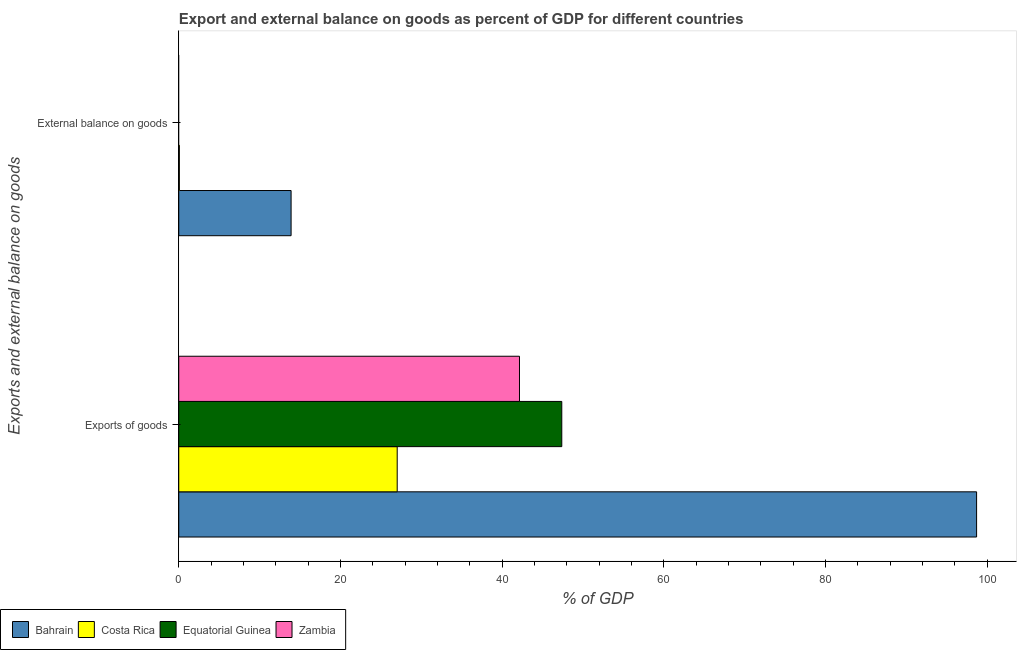How many groups of bars are there?
Your answer should be very brief. 2. Are the number of bars on each tick of the Y-axis equal?
Provide a succinct answer. No. How many bars are there on the 2nd tick from the top?
Your response must be concise. 4. What is the label of the 2nd group of bars from the top?
Your answer should be compact. Exports of goods. What is the external balance on goods as percentage of gdp in Costa Rica?
Your answer should be very brief. 0.07. Across all countries, what is the maximum export of goods as percentage of gdp?
Offer a terse response. 98.71. Across all countries, what is the minimum export of goods as percentage of gdp?
Make the answer very short. 27.03. In which country was the export of goods as percentage of gdp maximum?
Provide a short and direct response. Bahrain. What is the total external balance on goods as percentage of gdp in the graph?
Provide a short and direct response. 13.97. What is the difference between the external balance on goods as percentage of gdp in Bahrain and that in Costa Rica?
Offer a very short reply. 13.83. What is the difference between the external balance on goods as percentage of gdp in Zambia and the export of goods as percentage of gdp in Bahrain?
Keep it short and to the point. -98.71. What is the average export of goods as percentage of gdp per country?
Offer a terse response. 53.82. What is the difference between the export of goods as percentage of gdp and external balance on goods as percentage of gdp in Costa Rica?
Your answer should be very brief. 26.95. What is the ratio of the export of goods as percentage of gdp in Costa Rica to that in Equatorial Guinea?
Give a very brief answer. 0.57. Is the export of goods as percentage of gdp in Zambia less than that in Equatorial Guinea?
Provide a short and direct response. Yes. In how many countries, is the export of goods as percentage of gdp greater than the average export of goods as percentage of gdp taken over all countries?
Provide a succinct answer. 1. How many bars are there?
Your answer should be compact. 6. How many countries are there in the graph?
Make the answer very short. 4. Are the values on the major ticks of X-axis written in scientific E-notation?
Ensure brevity in your answer.  No. Where does the legend appear in the graph?
Your response must be concise. Bottom left. How many legend labels are there?
Keep it short and to the point. 4. What is the title of the graph?
Your answer should be compact. Export and external balance on goods as percent of GDP for different countries. What is the label or title of the X-axis?
Provide a short and direct response. % of GDP. What is the label or title of the Y-axis?
Offer a very short reply. Exports and external balance on goods. What is the % of GDP in Bahrain in Exports of goods?
Ensure brevity in your answer.  98.71. What is the % of GDP in Costa Rica in Exports of goods?
Your response must be concise. 27.03. What is the % of GDP in Equatorial Guinea in Exports of goods?
Your response must be concise. 47.39. What is the % of GDP in Zambia in Exports of goods?
Provide a succinct answer. 42.15. What is the % of GDP in Bahrain in External balance on goods?
Ensure brevity in your answer.  13.9. What is the % of GDP in Costa Rica in External balance on goods?
Make the answer very short. 0.07. What is the % of GDP of Equatorial Guinea in External balance on goods?
Offer a terse response. 0. Across all Exports and external balance on goods, what is the maximum % of GDP of Bahrain?
Keep it short and to the point. 98.71. Across all Exports and external balance on goods, what is the maximum % of GDP of Costa Rica?
Make the answer very short. 27.03. Across all Exports and external balance on goods, what is the maximum % of GDP in Equatorial Guinea?
Your answer should be very brief. 47.39. Across all Exports and external balance on goods, what is the maximum % of GDP of Zambia?
Give a very brief answer. 42.15. Across all Exports and external balance on goods, what is the minimum % of GDP of Bahrain?
Give a very brief answer. 13.9. Across all Exports and external balance on goods, what is the minimum % of GDP in Costa Rica?
Make the answer very short. 0.07. Across all Exports and external balance on goods, what is the minimum % of GDP of Zambia?
Provide a succinct answer. 0. What is the total % of GDP in Bahrain in the graph?
Ensure brevity in your answer.  112.61. What is the total % of GDP of Costa Rica in the graph?
Offer a very short reply. 27.1. What is the total % of GDP of Equatorial Guinea in the graph?
Your response must be concise. 47.39. What is the total % of GDP of Zambia in the graph?
Keep it short and to the point. 42.15. What is the difference between the % of GDP of Bahrain in Exports of goods and that in External balance on goods?
Make the answer very short. 84.81. What is the difference between the % of GDP in Costa Rica in Exports of goods and that in External balance on goods?
Give a very brief answer. 26.95. What is the difference between the % of GDP in Bahrain in Exports of goods and the % of GDP in Costa Rica in External balance on goods?
Provide a short and direct response. 98.64. What is the average % of GDP in Bahrain per Exports and external balance on goods?
Give a very brief answer. 56.3. What is the average % of GDP of Costa Rica per Exports and external balance on goods?
Your response must be concise. 13.55. What is the average % of GDP of Equatorial Guinea per Exports and external balance on goods?
Offer a terse response. 23.69. What is the average % of GDP of Zambia per Exports and external balance on goods?
Offer a very short reply. 21.08. What is the difference between the % of GDP in Bahrain and % of GDP in Costa Rica in Exports of goods?
Provide a short and direct response. 71.68. What is the difference between the % of GDP in Bahrain and % of GDP in Equatorial Guinea in Exports of goods?
Give a very brief answer. 51.32. What is the difference between the % of GDP of Bahrain and % of GDP of Zambia in Exports of goods?
Your answer should be compact. 56.56. What is the difference between the % of GDP in Costa Rica and % of GDP in Equatorial Guinea in Exports of goods?
Provide a succinct answer. -20.36. What is the difference between the % of GDP in Costa Rica and % of GDP in Zambia in Exports of goods?
Provide a short and direct response. -15.13. What is the difference between the % of GDP in Equatorial Guinea and % of GDP in Zambia in Exports of goods?
Provide a short and direct response. 5.23. What is the difference between the % of GDP in Bahrain and % of GDP in Costa Rica in External balance on goods?
Ensure brevity in your answer.  13.83. What is the ratio of the % of GDP of Bahrain in Exports of goods to that in External balance on goods?
Offer a very short reply. 7.1. What is the ratio of the % of GDP of Costa Rica in Exports of goods to that in External balance on goods?
Offer a very short reply. 378.27. What is the difference between the highest and the second highest % of GDP of Bahrain?
Offer a terse response. 84.81. What is the difference between the highest and the second highest % of GDP of Costa Rica?
Offer a very short reply. 26.95. What is the difference between the highest and the lowest % of GDP of Bahrain?
Your response must be concise. 84.81. What is the difference between the highest and the lowest % of GDP of Costa Rica?
Keep it short and to the point. 26.95. What is the difference between the highest and the lowest % of GDP in Equatorial Guinea?
Make the answer very short. 47.39. What is the difference between the highest and the lowest % of GDP of Zambia?
Give a very brief answer. 42.15. 